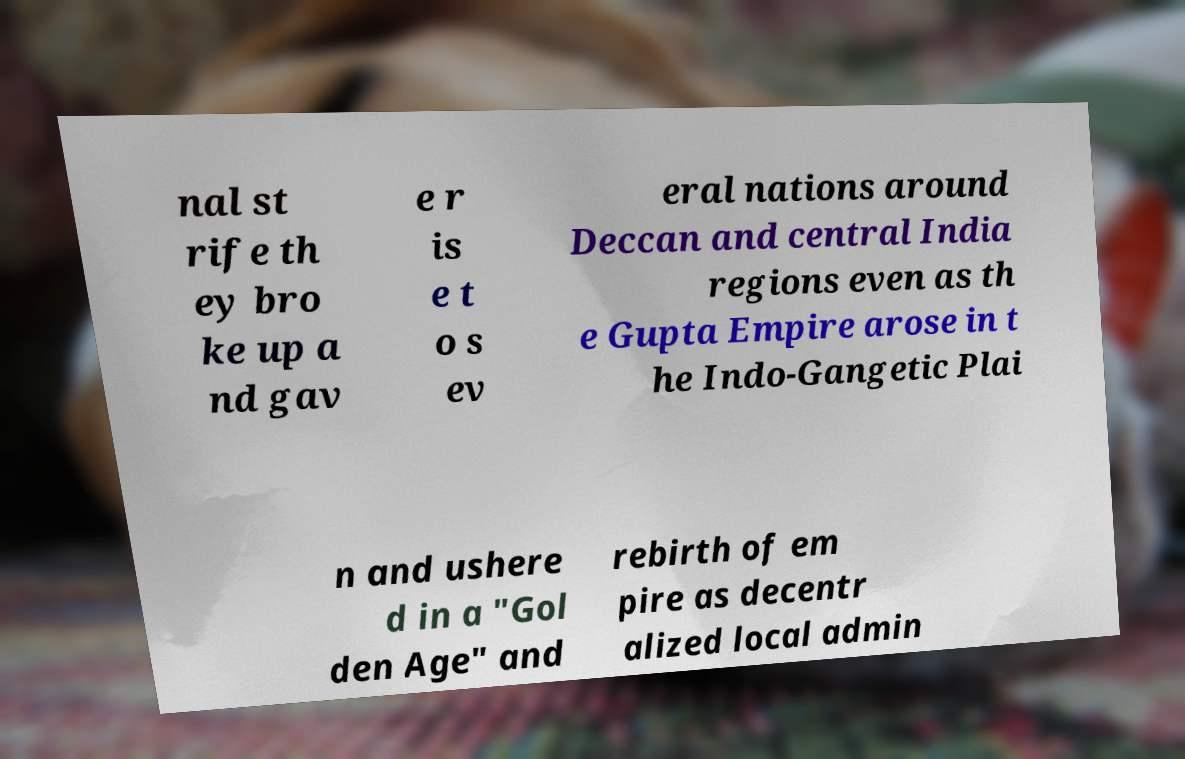Can you read and provide the text displayed in the image?This photo seems to have some interesting text. Can you extract and type it out for me? nal st rife th ey bro ke up a nd gav e r is e t o s ev eral nations around Deccan and central India regions even as th e Gupta Empire arose in t he Indo-Gangetic Plai n and ushere d in a "Gol den Age" and rebirth of em pire as decentr alized local admin 